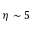Convert formula to latex. <formula><loc_0><loc_0><loc_500><loc_500>\eta \sim 5</formula> 